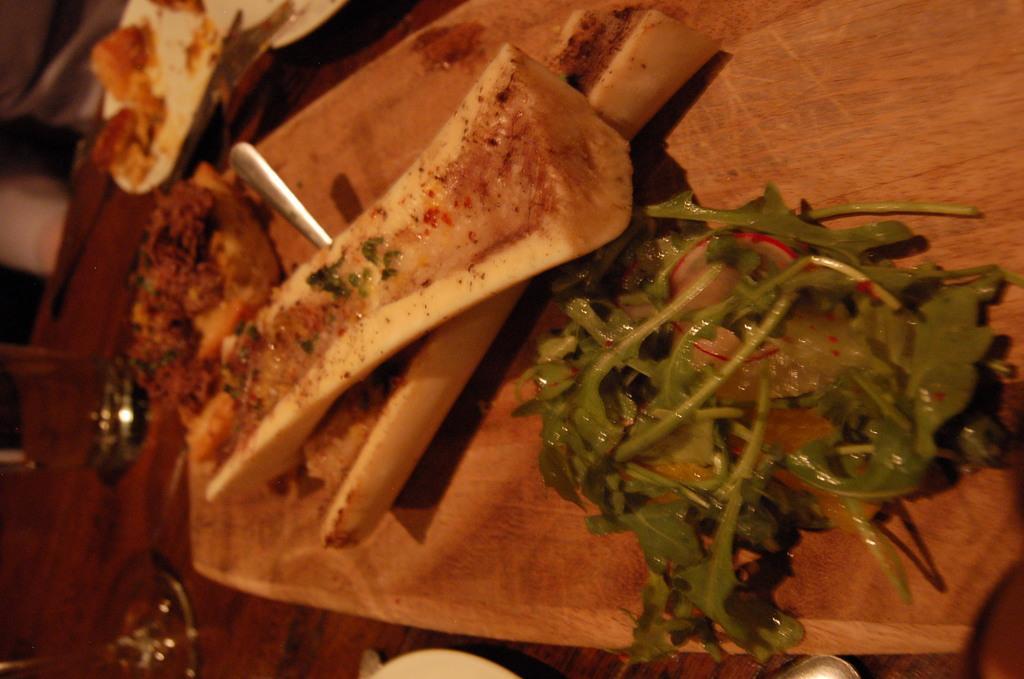How would you summarize this image in a sentence or two? In this image in front there are food items on a wooden board. There is a spoon. Beside the bord there are food items on a plate. There are glasses which was placed on the table. 